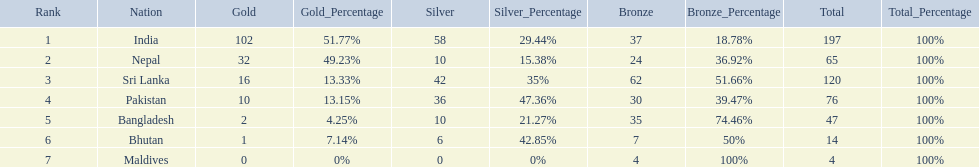What were the total amount won of medals by nations in the 1999 south asian games? 197, 65, 120, 76, 47, 14, 4. Which amount was the lowest? 4. Parse the table in full. {'header': ['Rank', 'Nation', 'Gold', 'Gold_Percentage', 'Silver', 'Silver_Percentage', 'Bronze', 'Bronze_Percentage', 'Total', 'Total_Percentage'], 'rows': [['1', 'India', '102', '51.77%', '58', '29.44%', '37', '18.78%', '197', '100%'], ['2', 'Nepal', '32', '49.23%', '10', '15.38%', '24', '36.92%', '65', '100%'], ['3', 'Sri Lanka', '16', '13.33%', '42', '35%', '62', '51.66%', '120', '100%'], ['4', 'Pakistan', '10', '13.15%', '36', '47.36%', '30', '39.47%', '76', '100%'], ['5', 'Bangladesh', '2', '4.25%', '10', '21.27%', '35', '74.46%', '47', '100%'], ['6', 'Bhutan', '1', '7.14%', '6', '42.85%', '7', '50%', '14', '100%'], ['7', 'Maldives', '0', '0%', '0', '0%', '4', '100%', '4', '100%']]} Which nation had this amount? Maldives. 